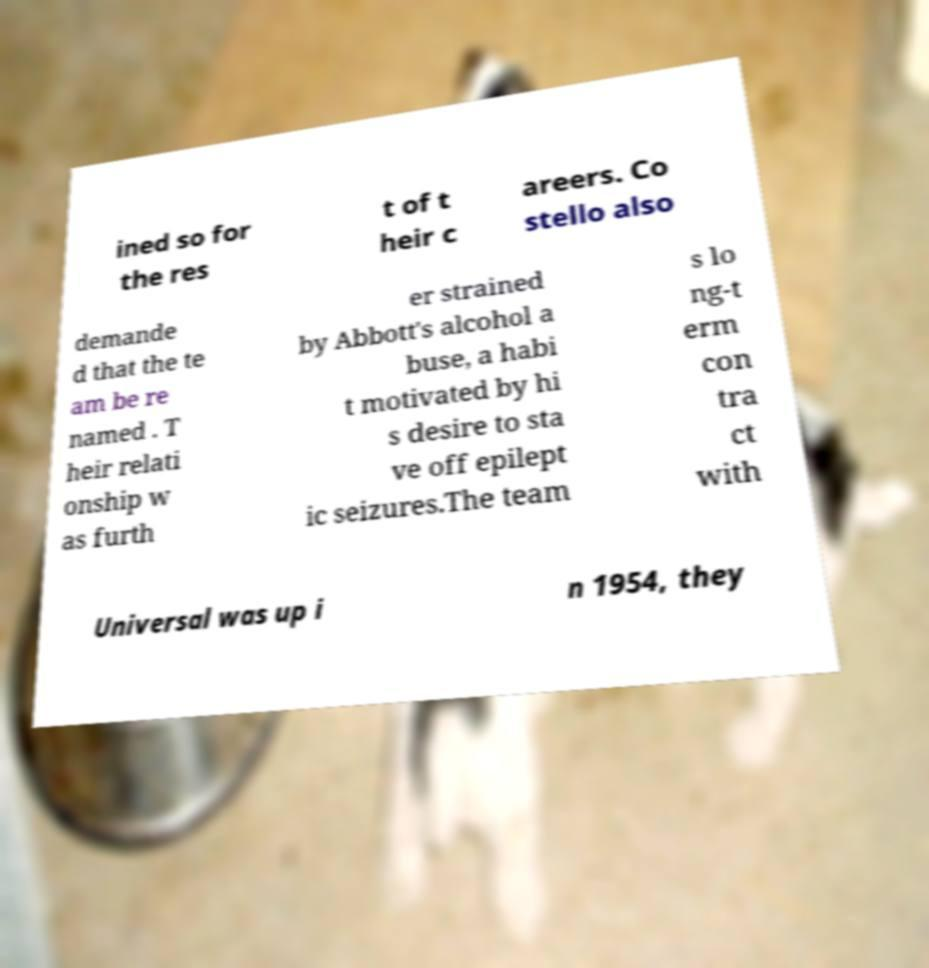There's text embedded in this image that I need extracted. Can you transcribe it verbatim? ined so for the res t of t heir c areers. Co stello also demande d that the te am be re named . T heir relati onship w as furth er strained by Abbott's alcohol a buse, a habi t motivated by hi s desire to sta ve off epilept ic seizures.The team s lo ng-t erm con tra ct with Universal was up i n 1954, they 